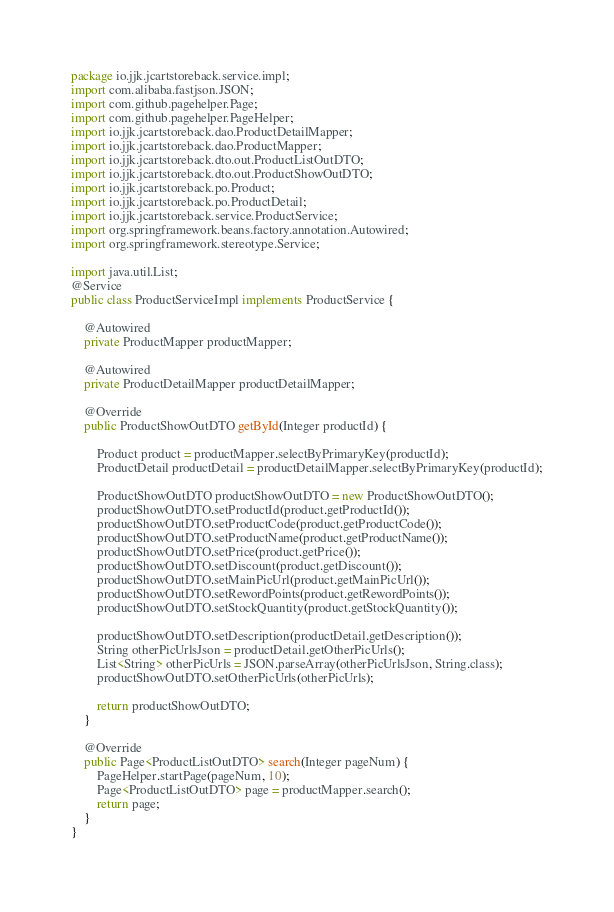<code> <loc_0><loc_0><loc_500><loc_500><_Java_>package io.jjk.jcartstoreback.service.impl;
import com.alibaba.fastjson.JSON;
import com.github.pagehelper.Page;
import com.github.pagehelper.PageHelper;
import io.jjk.jcartstoreback.dao.ProductDetailMapper;
import io.jjk.jcartstoreback.dao.ProductMapper;
import io.jjk.jcartstoreback.dto.out.ProductListOutDTO;
import io.jjk.jcartstoreback.dto.out.ProductShowOutDTO;
import io.jjk.jcartstoreback.po.Product;
import io.jjk.jcartstoreback.po.ProductDetail;
import io.jjk.jcartstoreback.service.ProductService;
import org.springframework.beans.factory.annotation.Autowired;
import org.springframework.stereotype.Service;

import java.util.List;
@Service
public class ProductServiceImpl implements ProductService {

    @Autowired
    private ProductMapper productMapper;

    @Autowired
    private ProductDetailMapper productDetailMapper;

    @Override
    public ProductShowOutDTO getById(Integer productId) {

        Product product = productMapper.selectByPrimaryKey(productId);
        ProductDetail productDetail = productDetailMapper.selectByPrimaryKey(productId);

        ProductShowOutDTO productShowOutDTO = new ProductShowOutDTO();
        productShowOutDTO.setProductId(product.getProductId());
        productShowOutDTO.setProductCode(product.getProductCode());
        productShowOutDTO.setProductName(product.getProductName());
        productShowOutDTO.setPrice(product.getPrice());
        productShowOutDTO.setDiscount(product.getDiscount());
        productShowOutDTO.setMainPicUrl(product.getMainPicUrl());
        productShowOutDTO.setRewordPoints(product.getRewordPoints());
        productShowOutDTO.setStockQuantity(product.getStockQuantity());

        productShowOutDTO.setDescription(productDetail.getDescription());
        String otherPicUrlsJson = productDetail.getOtherPicUrls();
        List<String> otherPicUrls = JSON.parseArray(otherPicUrlsJson, String.class);
        productShowOutDTO.setOtherPicUrls(otherPicUrls);

        return productShowOutDTO;
    }

    @Override
    public Page<ProductListOutDTO> search(Integer pageNum) {
        PageHelper.startPage(pageNum, 10);
        Page<ProductListOutDTO> page = productMapper.search();
        return page;
    }
}
</code> 